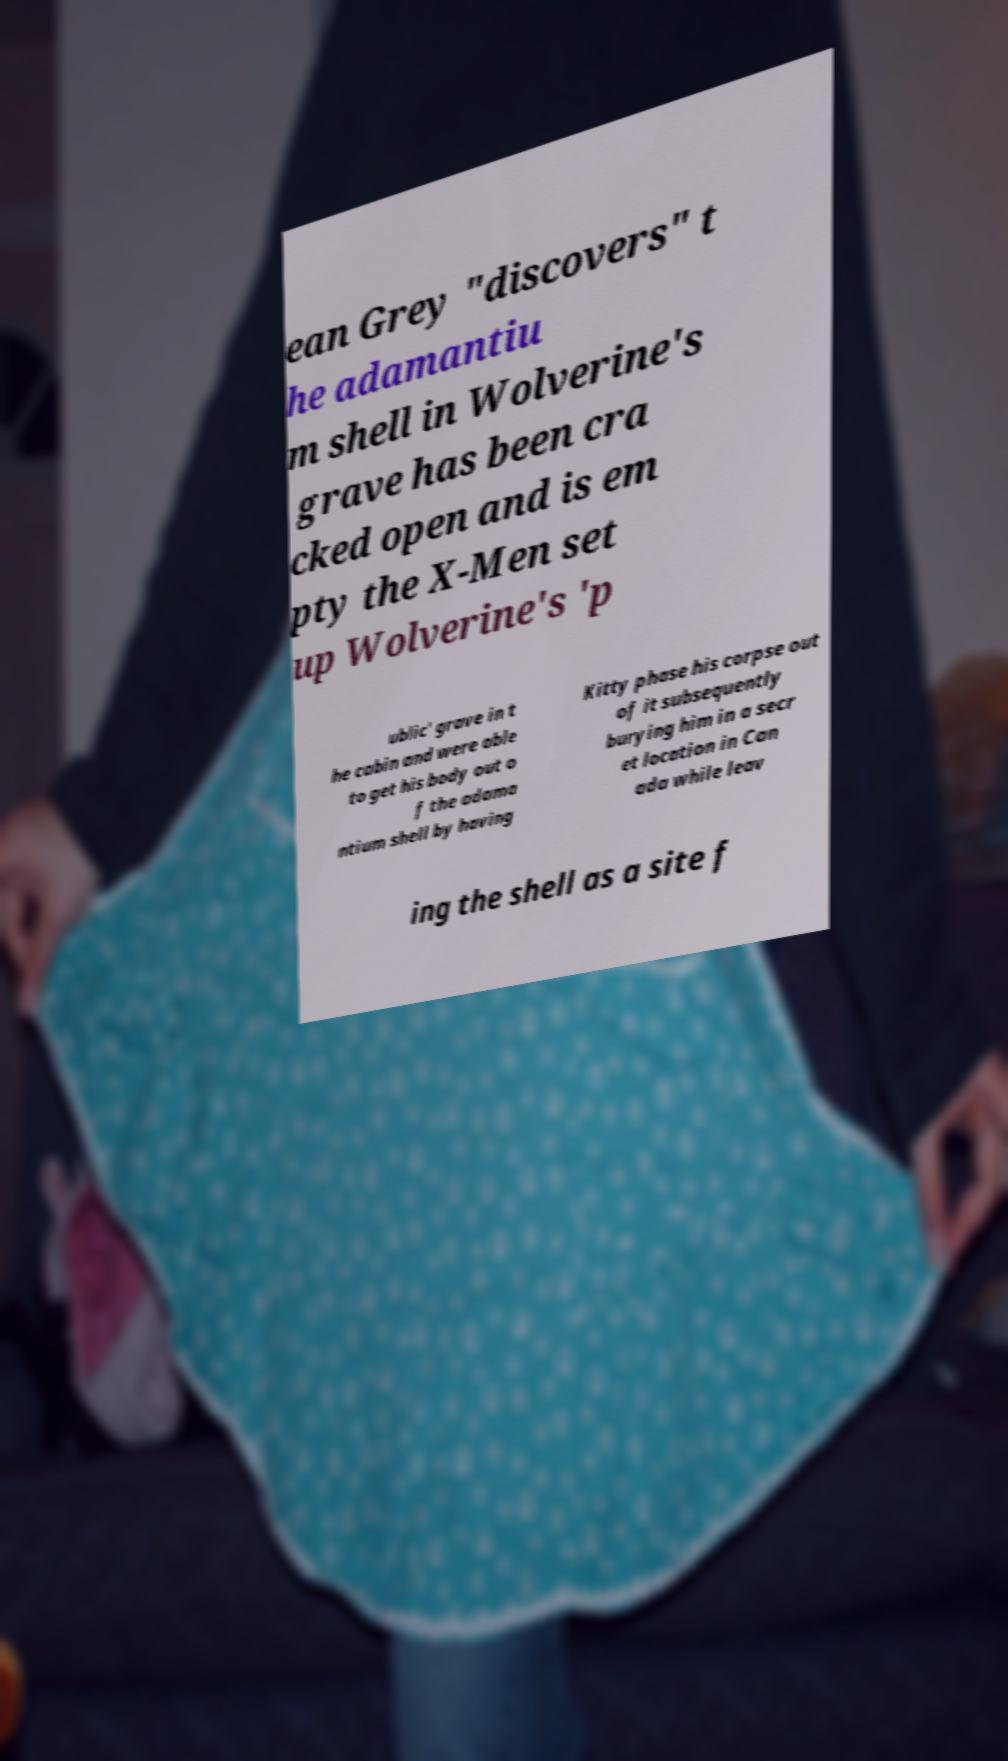I need the written content from this picture converted into text. Can you do that? ean Grey "discovers" t he adamantiu m shell in Wolverine's grave has been cra cked open and is em pty the X-Men set up Wolverine's 'p ublic' grave in t he cabin and were able to get his body out o f the adama ntium shell by having Kitty phase his corpse out of it subsequently burying him in a secr et location in Can ada while leav ing the shell as a site f 